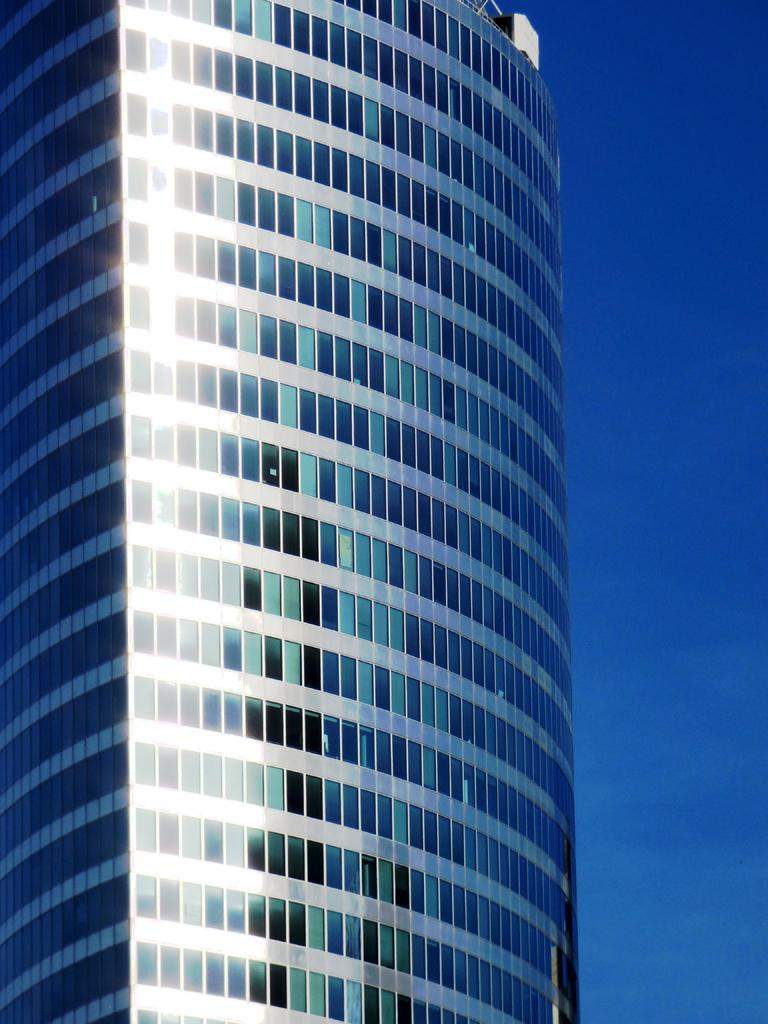What type of structure is the main subject of the image? There is a tall building in the image. What features can be observed on the building? The building has many windows and glasses. What is visible at the top of the image? The sky is visible at the top of the image. Can you tell me how many faucets are installed on the building in the image? There is no information about faucets in the image; it only shows a tall building with windows and glasses. Is the son of the building owner visible in the image? There is no person mentioned or visible in the image, only the tall building with windows and glasses. 